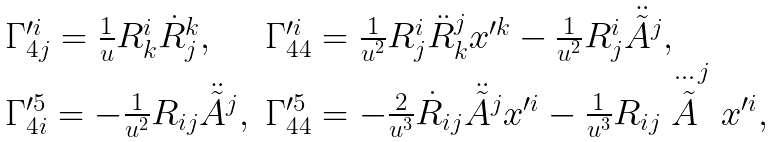<formula> <loc_0><loc_0><loc_500><loc_500>\begin{array} { l l } \Gamma ^ { \prime i } _ { 4 j } = \frac { 1 } { u } R ^ { i } _ { k } \dot { R } _ { j } ^ { k } , & \Gamma ^ { \prime i } _ { 4 4 } = \frac { 1 } { u ^ { 2 } } R ^ { i } _ { j } \ddot { R } _ { k } ^ { j } x ^ { \prime k } - \frac { 1 } { u ^ { 2 } } R ^ { i } _ { j } \ddot { \tilde { A } } ^ { j } , \\ \Gamma ^ { \prime 5 } _ { 4 i } = - \frac { 1 } { u ^ { 2 } } R _ { i j } \ddot { \tilde { A } } ^ { j } , & \Gamma ^ { \prime 5 } _ { 4 4 } = - \frac { 2 } { u ^ { 3 } } \dot { R } _ { i j } \ddot { \tilde { A } } ^ { j } x ^ { \prime i } - \frac { 1 } { u ^ { 3 } } R _ { i j } \stackrel { \cdots } { \tilde { A } } ^ { j } x ^ { \prime i } , \end{array}</formula> 